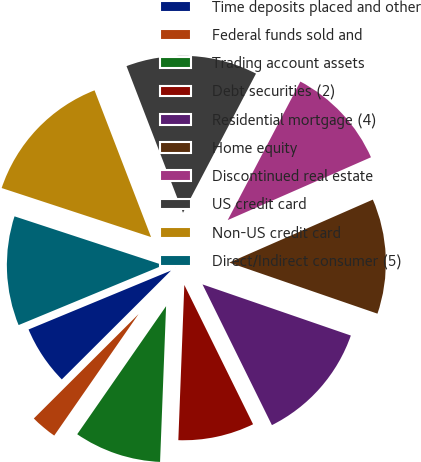Convert chart to OTSL. <chart><loc_0><loc_0><loc_500><loc_500><pie_chart><fcel>Time deposits placed and other<fcel>Federal funds sold and<fcel>Trading account assets<fcel>Debt securities (2)<fcel>Residential mortgage (4)<fcel>Home equity<fcel>Discontinued real estate<fcel>US credit card<fcel>Non-US credit card<fcel>Direct/Indirect consumer (5)<nl><fcel>6.23%<fcel>2.87%<fcel>9.04%<fcel>7.91%<fcel>12.42%<fcel>11.86%<fcel>10.73%<fcel>13.54%<fcel>14.1%<fcel>11.29%<nl></chart> 